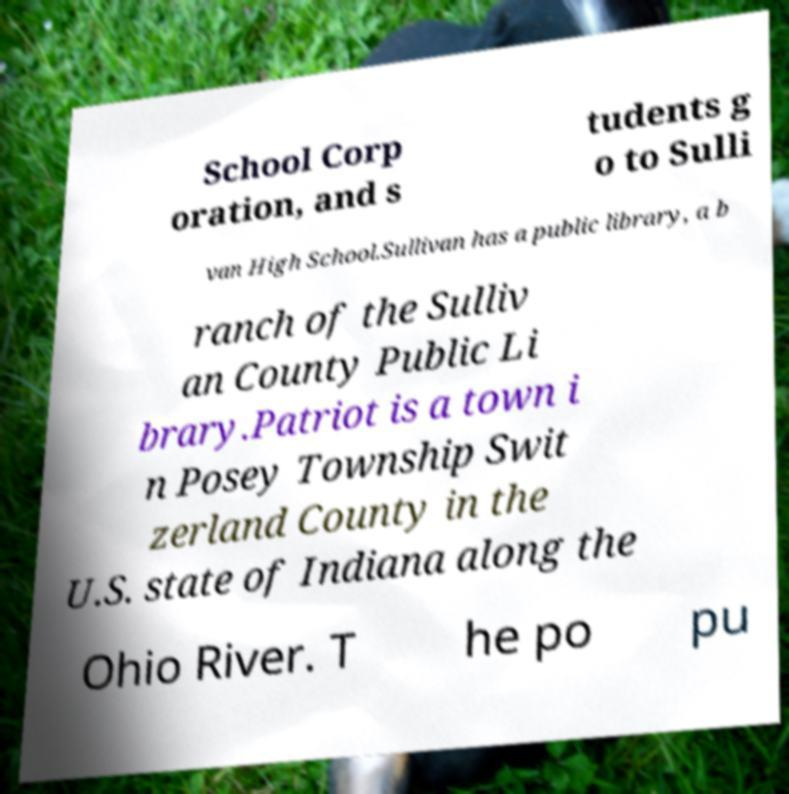I need the written content from this picture converted into text. Can you do that? School Corp oration, and s tudents g o to Sulli van High School.Sullivan has a public library, a b ranch of the Sulliv an County Public Li brary.Patriot is a town i n Posey Township Swit zerland County in the U.S. state of Indiana along the Ohio River. T he po pu 